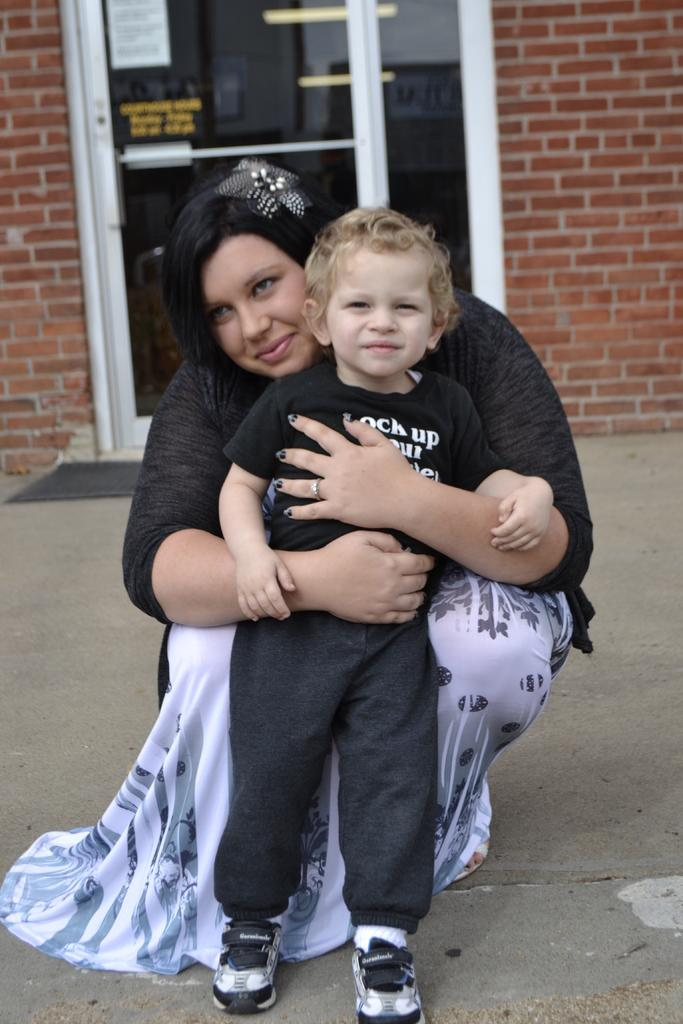Who is the main subject in the image? There is a woman in the image. What is the woman doing in the image? The woman is sitting and holding a boy in her hands. What can be seen in the background of the image? There is a glass door and a wall in the background of the image. What is the purpose of the needle in the image? There is no needle present in the image. 